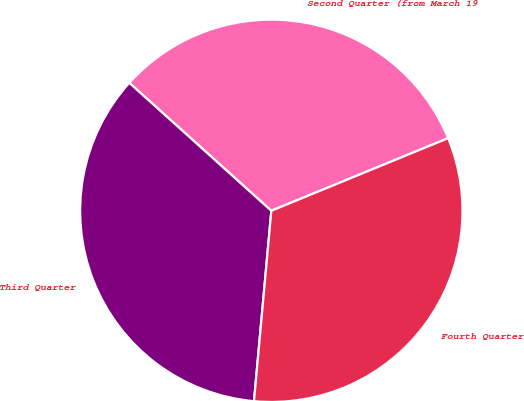Convert chart. <chart><loc_0><loc_0><loc_500><loc_500><pie_chart><fcel>Second Quarter (from March 19<fcel>Third Quarter<fcel>Fourth Quarter<nl><fcel>32.13%<fcel>35.23%<fcel>32.65%<nl></chart> 